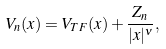Convert formula to latex. <formula><loc_0><loc_0><loc_500><loc_500>V _ { n } ( { x } ) = V _ { T F } ( { x } ) + \frac { Z _ { n } } { | { x } | ^ { \nu } } ,</formula> 